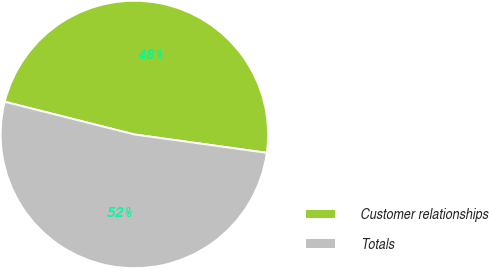Convert chart. <chart><loc_0><loc_0><loc_500><loc_500><pie_chart><fcel>Customer relationships<fcel>Totals<nl><fcel>48.26%<fcel>51.74%<nl></chart> 